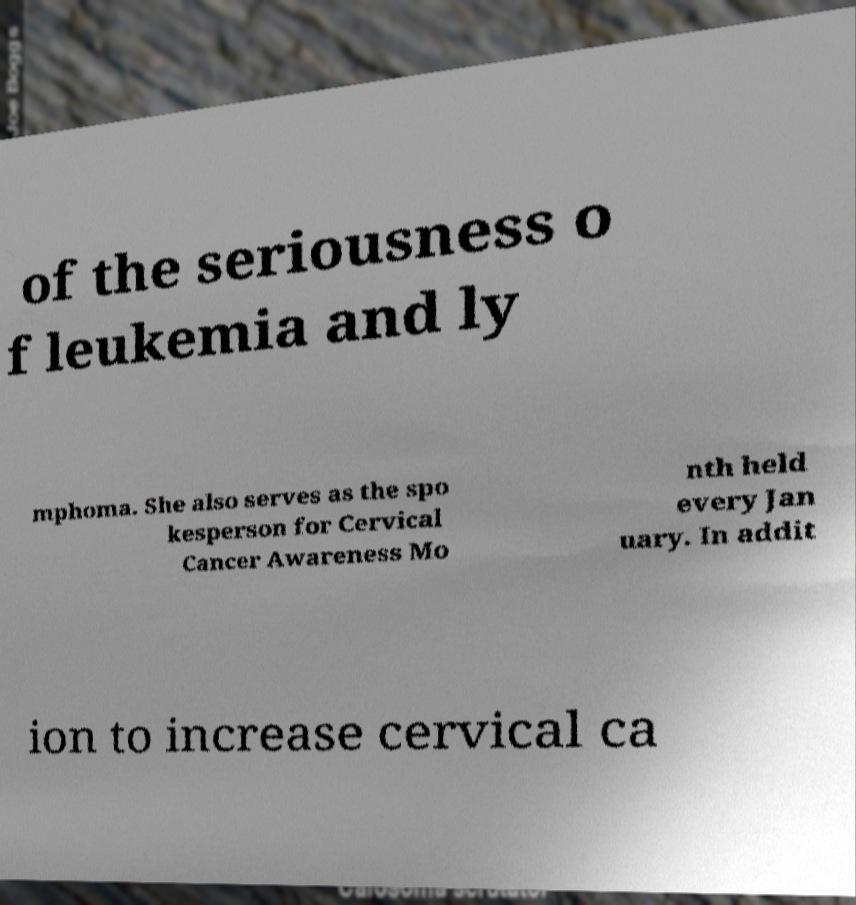Please identify and transcribe the text found in this image. of the seriousness o f leukemia and ly mphoma. She also serves as the spo kesperson for Cervical Cancer Awareness Mo nth held every Jan uary. In addit ion to increase cervical ca 